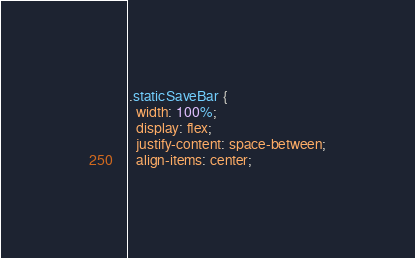Convert code to text. <code><loc_0><loc_0><loc_500><loc_500><_CSS_>
.staticSaveBar {
  width: 100%;
  display: flex;
  justify-content: space-between;
  align-items: center;</code> 